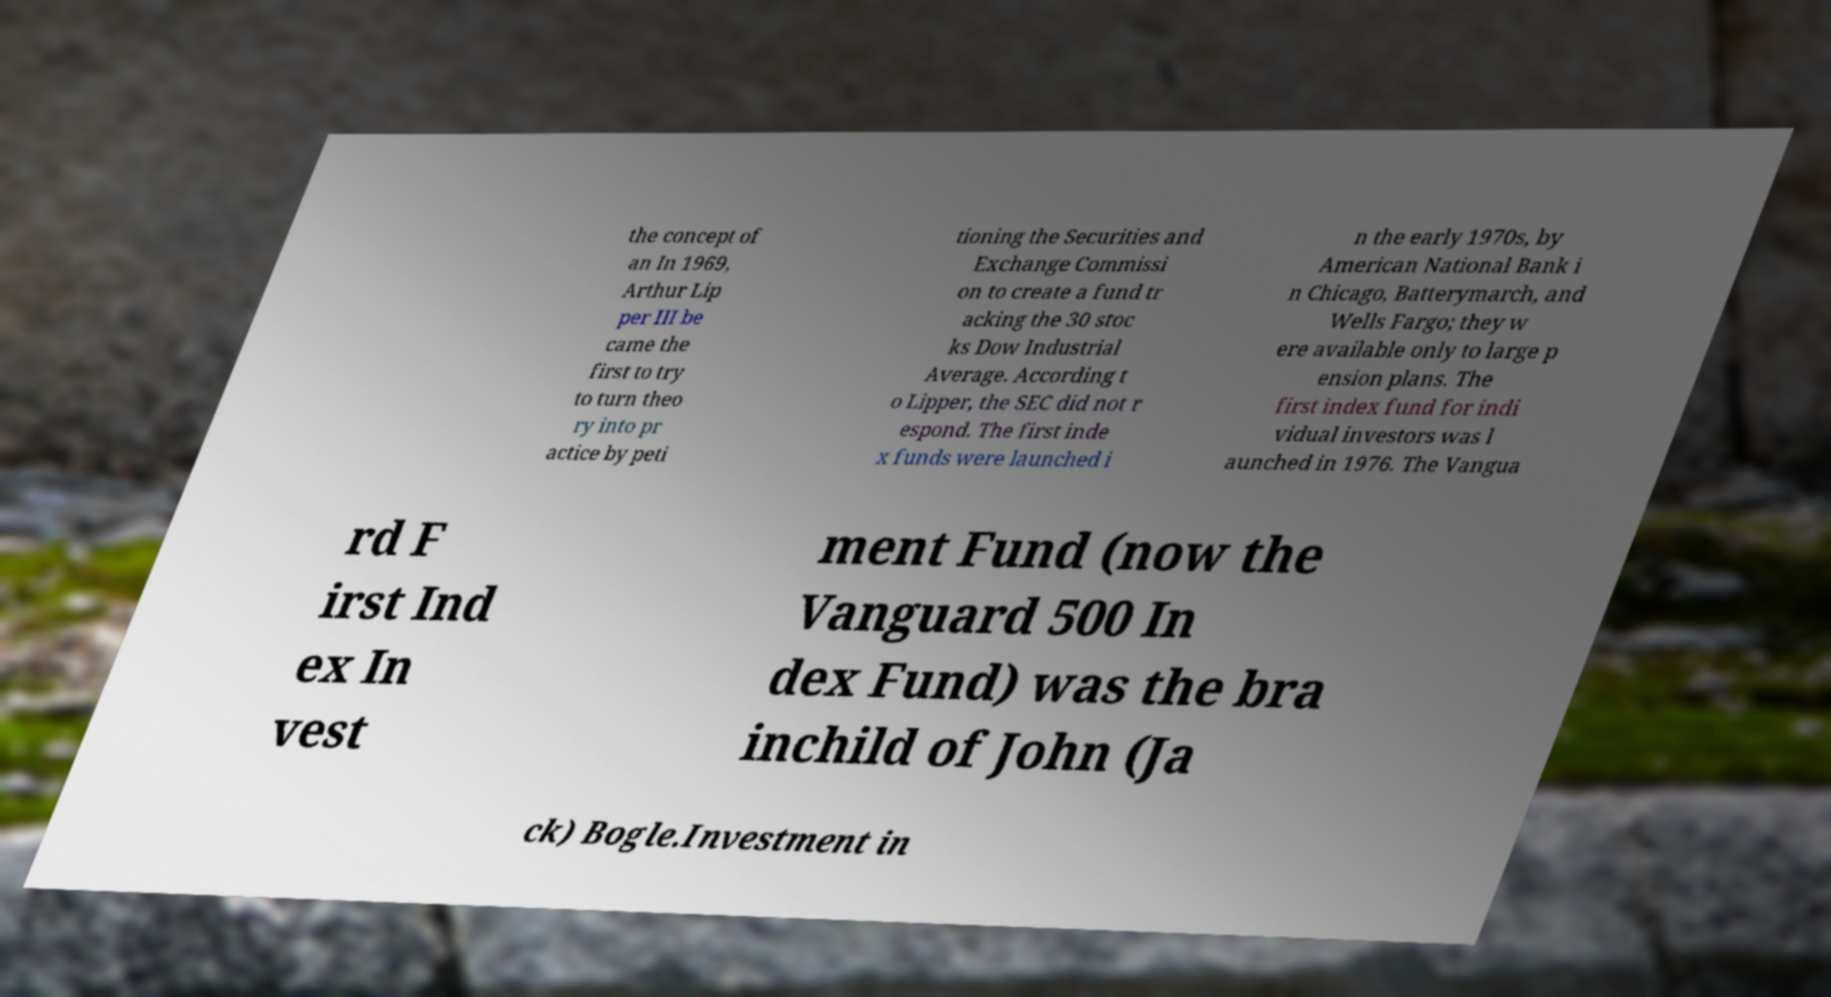Could you extract and type out the text from this image? the concept of an In 1969, Arthur Lip per III be came the first to try to turn theo ry into pr actice by peti tioning the Securities and Exchange Commissi on to create a fund tr acking the 30 stoc ks Dow Industrial Average. According t o Lipper, the SEC did not r espond. The first inde x funds were launched i n the early 1970s, by American National Bank i n Chicago, Batterymarch, and Wells Fargo; they w ere available only to large p ension plans. The first index fund for indi vidual investors was l aunched in 1976. The Vangua rd F irst Ind ex In vest ment Fund (now the Vanguard 500 In dex Fund) was the bra inchild of John (Ja ck) Bogle.Investment in 